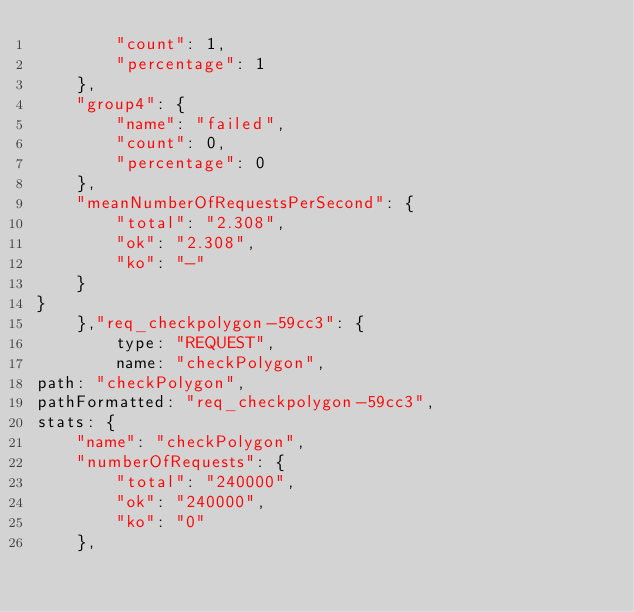Convert code to text. <code><loc_0><loc_0><loc_500><loc_500><_JavaScript_>        "count": 1,
        "percentage": 1
    },
    "group4": {
        "name": "failed",
        "count": 0,
        "percentage": 0
    },
    "meanNumberOfRequestsPerSecond": {
        "total": "2.308",
        "ok": "2.308",
        "ko": "-"
    }
}
    },"req_checkpolygon-59cc3": {
        type: "REQUEST",
        name: "checkPolygon",
path: "checkPolygon",
pathFormatted: "req_checkpolygon-59cc3",
stats: {
    "name": "checkPolygon",
    "numberOfRequests": {
        "total": "240000",
        "ok": "240000",
        "ko": "0"
    },</code> 